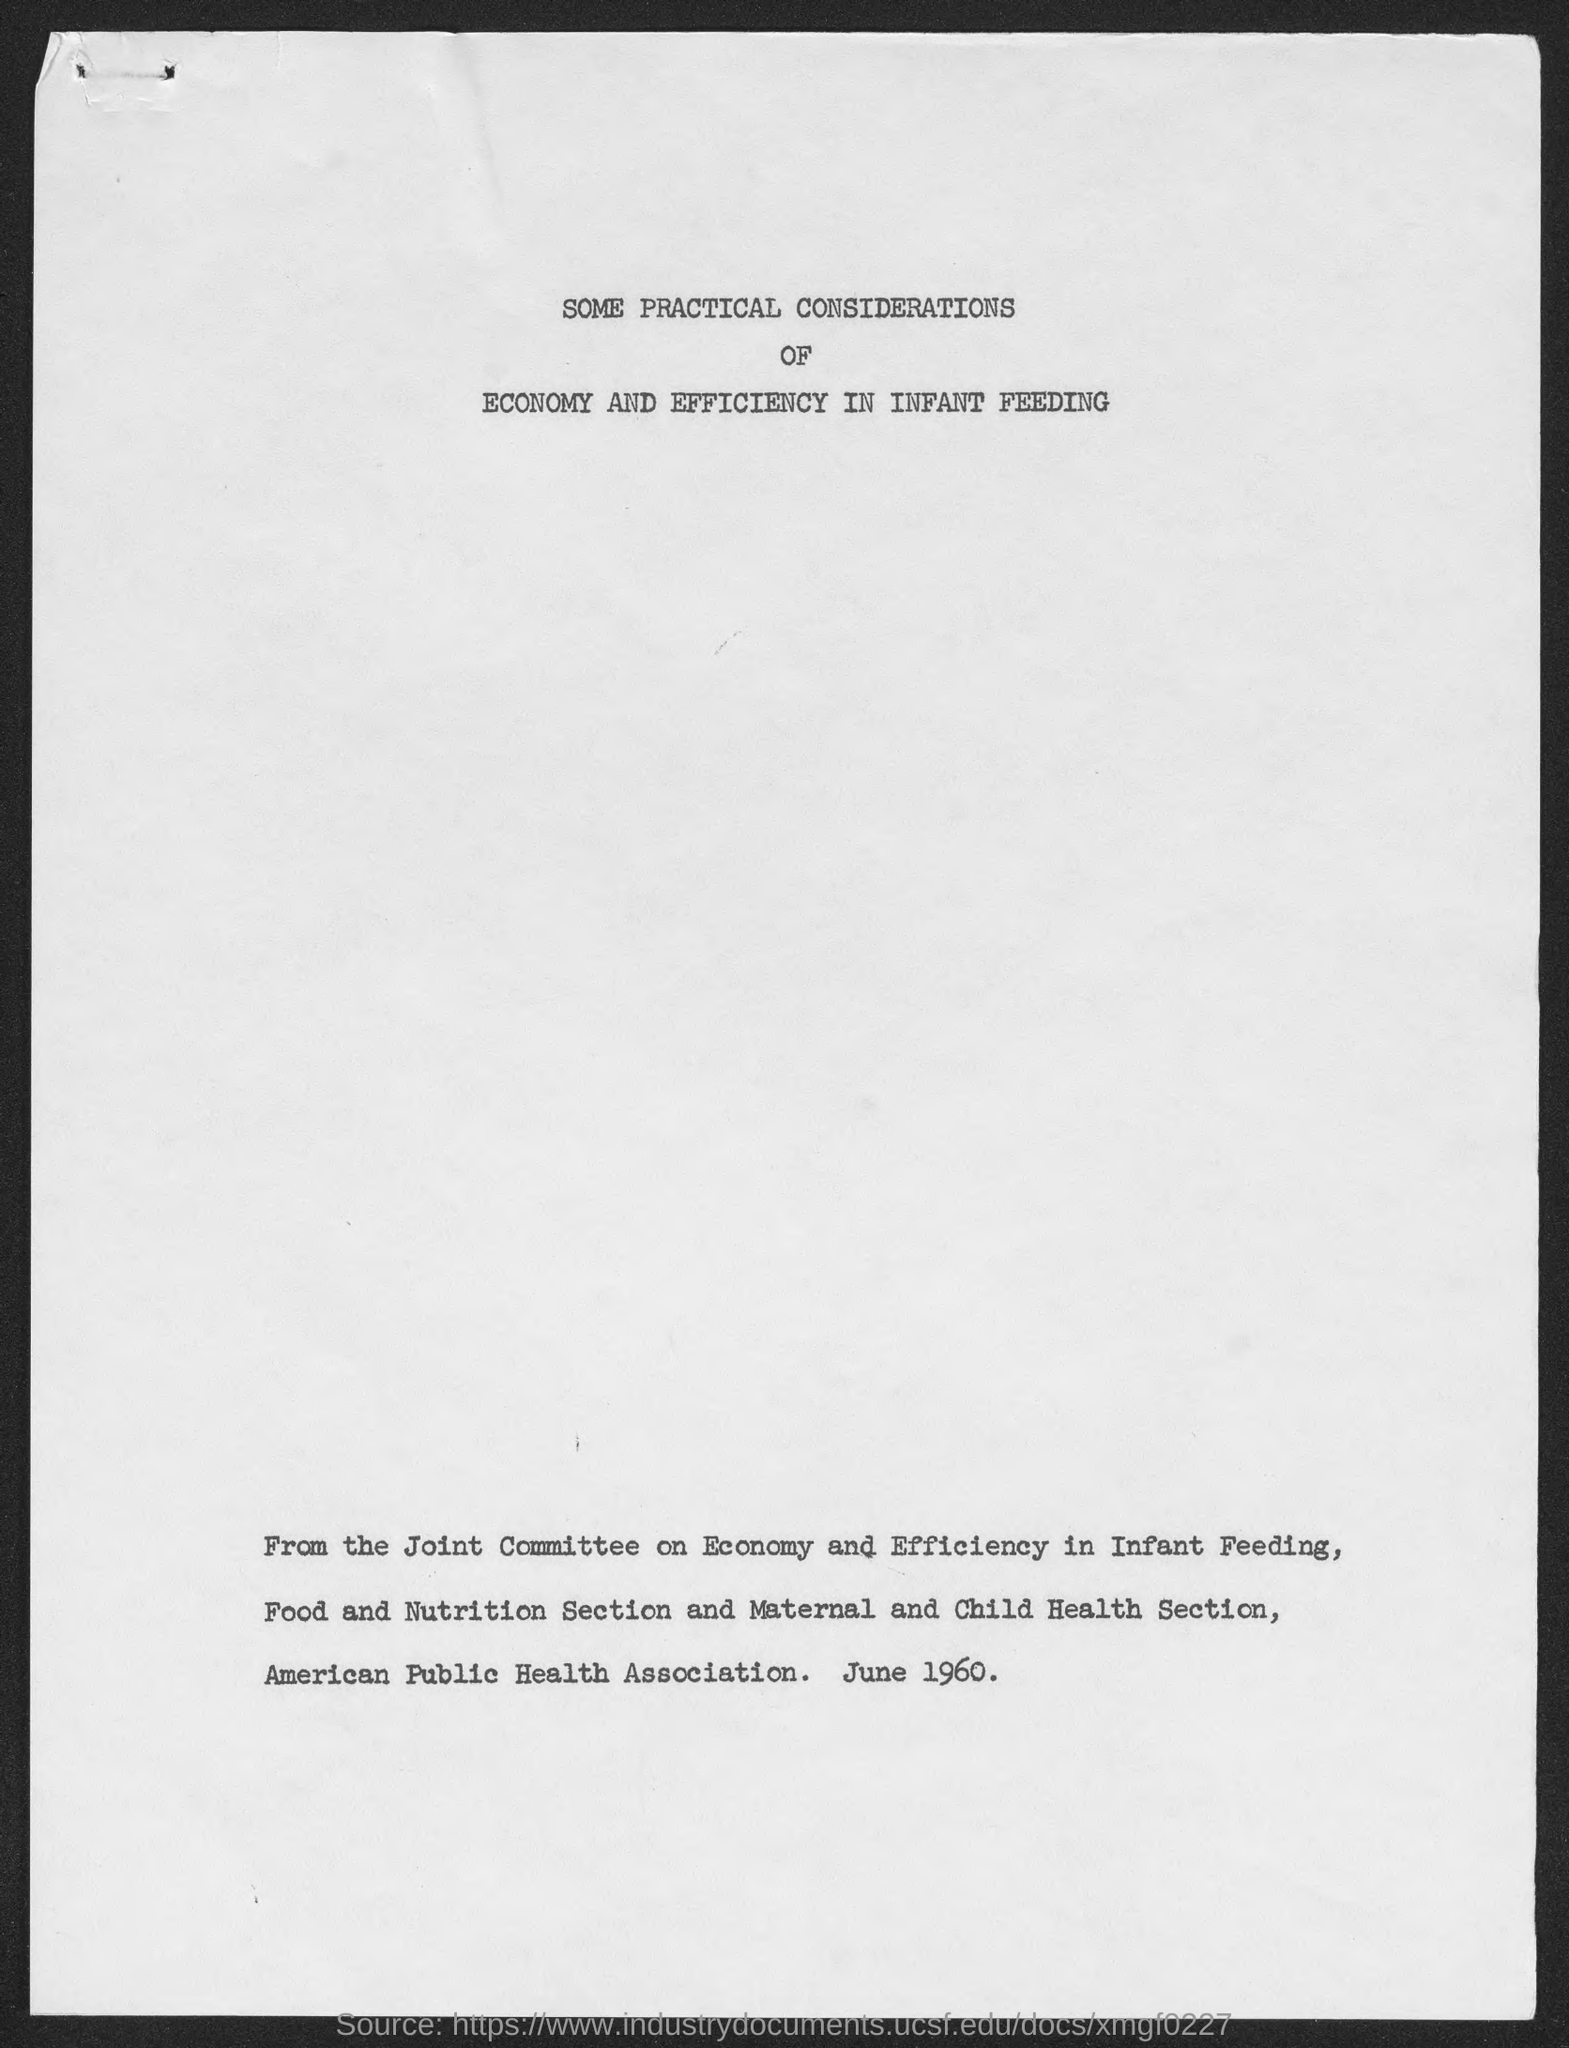Indicate a few pertinent items in this graphic. The date is June 1960, as indicated beside the American Public Health Association. 